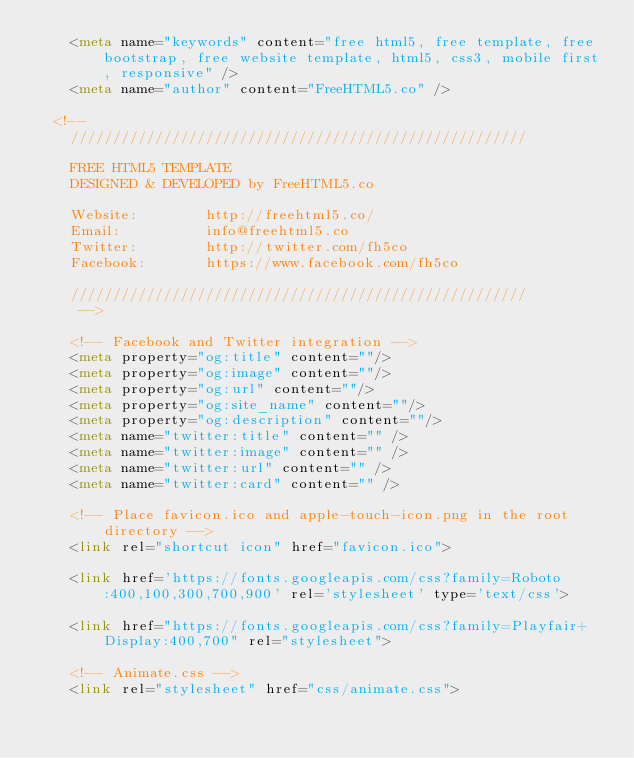<code> <loc_0><loc_0><loc_500><loc_500><_HTML_>	<meta name="keywords" content="free html5, free template, free bootstrap, free website template, html5, css3, mobile first, responsive" />
	<meta name="author" content="FreeHTML5.co" />

  <!-- 
	//////////////////////////////////////////////////////

	FREE HTML5 TEMPLATE 
	DESIGNED & DEVELOPED by FreeHTML5.co
		
	Website: 		http://freehtml5.co/
	Email: 			info@freehtml5.co
	Twitter: 		http://twitter.com/fh5co
	Facebook: 		https://www.facebook.com/fh5co

	//////////////////////////////////////////////////////
	 -->

  	<!-- Facebook and Twitter integration -->
	<meta property="og:title" content=""/>
	<meta property="og:image" content=""/>
	<meta property="og:url" content=""/>
	<meta property="og:site_name" content=""/>
	<meta property="og:description" content=""/>
	<meta name="twitter:title" content="" />
	<meta name="twitter:image" content="" />
	<meta name="twitter:url" content="" />
	<meta name="twitter:card" content="" />

	<!-- Place favicon.ico and apple-touch-icon.png in the root directory -->
	<link rel="shortcut icon" href="favicon.ico">

	<link href='https://fonts.googleapis.com/css?family=Roboto:400,100,300,700,900' rel='stylesheet' type='text/css'>

	<link href="https://fonts.googleapis.com/css?family=Playfair+Display:400,700" rel="stylesheet">
	
	<!-- Animate.css -->
	<link rel="stylesheet" href="css/animate.css"></code> 